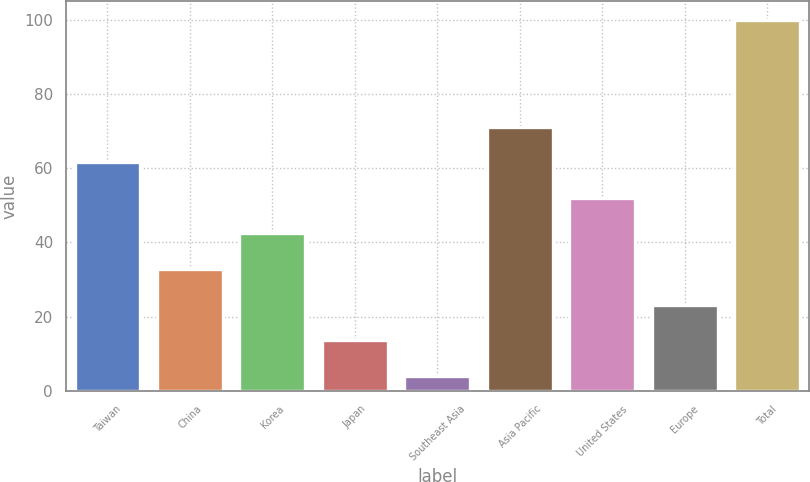Convert chart to OTSL. <chart><loc_0><loc_0><loc_500><loc_500><bar_chart><fcel>Taiwan<fcel>China<fcel>Korea<fcel>Japan<fcel>Southeast Asia<fcel>Asia Pacific<fcel>United States<fcel>Europe<fcel>Total<nl><fcel>61.6<fcel>32.8<fcel>42.4<fcel>13.6<fcel>4<fcel>71.2<fcel>52<fcel>23.2<fcel>100<nl></chart> 